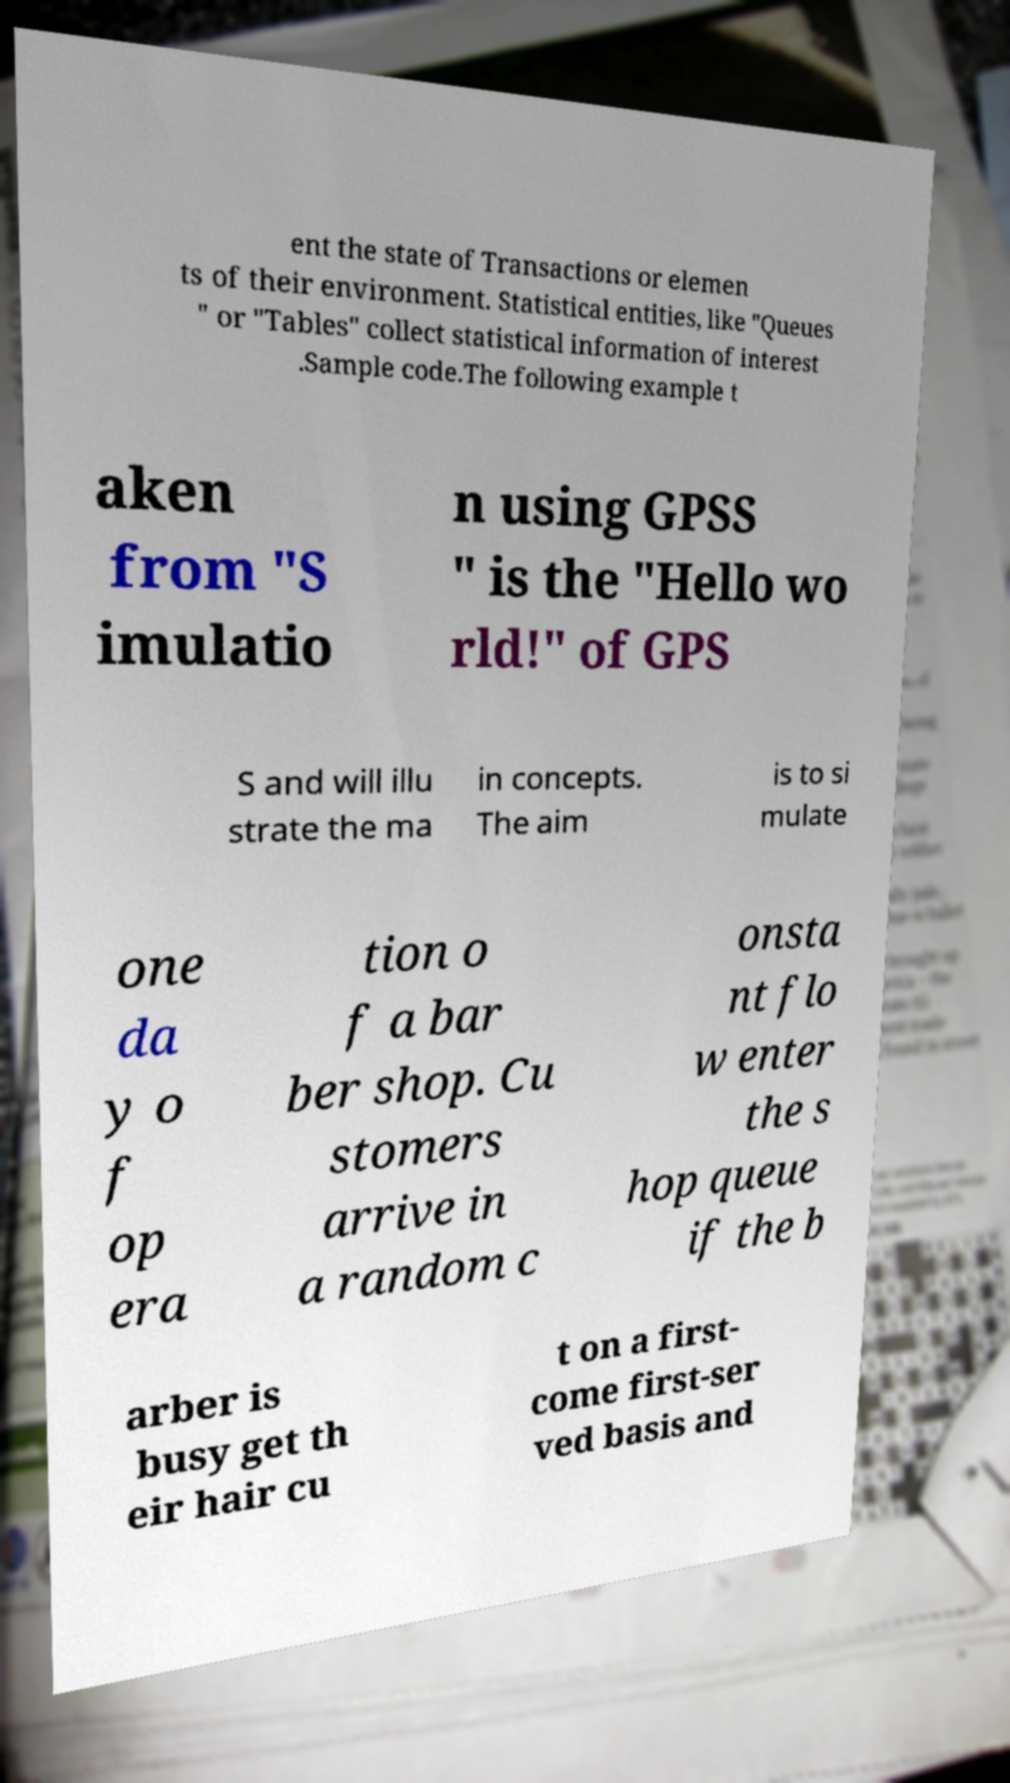Can you accurately transcribe the text from the provided image for me? ent the state of Transactions or elemen ts of their environment. Statistical entities, like "Queues " or "Tables" collect statistical information of interest .Sample code.The following example t aken from "S imulatio n using GPSS " is the "Hello wo rld!" of GPS S and will illu strate the ma in concepts. The aim is to si mulate one da y o f op era tion o f a bar ber shop. Cu stomers arrive in a random c onsta nt flo w enter the s hop queue if the b arber is busy get th eir hair cu t on a first- come first-ser ved basis and 